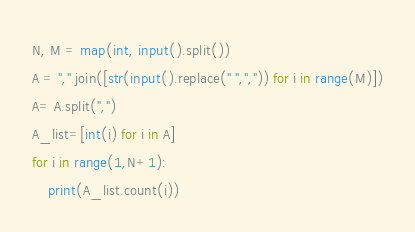<code> <loc_0><loc_0><loc_500><loc_500><_Python_>N, M = map(int, input().split())
A = ",".join([str(input().replace(" ",",")) for i in range(M)])
A= A.split(",")
A_list=[int(i) for i in A]
for i in range(1,N+1):
    print(A_list.count(i))</code> 